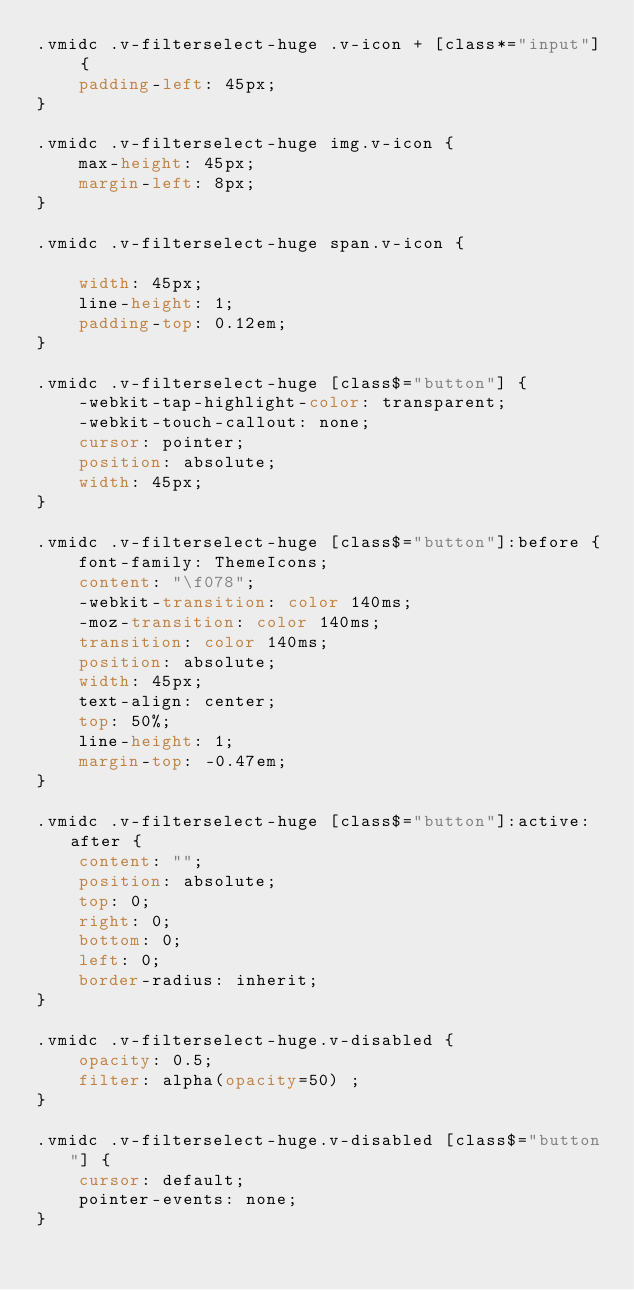Convert code to text. <code><loc_0><loc_0><loc_500><loc_500><_CSS_>.vmidc .v-filterselect-huge .v-icon + [class*="input"] {
	padding-left: 45px;
}

.vmidc .v-filterselect-huge img.v-icon {
	max-height: 45px;
	margin-left: 8px;
}

.vmidc .v-filterselect-huge span.v-icon {
	
	width: 45px;
	line-height: 1;
	padding-top: 0.12em;
}

.vmidc .v-filterselect-huge [class$="button"] {
	-webkit-tap-highlight-color: transparent;
	-webkit-touch-callout: none;
	cursor: pointer;
	position: absolute;
	width: 45px;
}

.vmidc .v-filterselect-huge [class$="button"]:before {
	font-family: ThemeIcons;
	content: "\f078";
	-webkit-transition: color 140ms;
	-moz-transition: color 140ms;
	transition: color 140ms;
	position: absolute;
	width: 45px;
	text-align: center;
	top: 50%;
	line-height: 1;
	margin-top: -0.47em;
}

.vmidc .v-filterselect-huge [class$="button"]:active:after {
	content: "";
	position: absolute;
	top: 0;
	right: 0;
	bottom: 0;
	left: 0;
	border-radius: inherit;
}

.vmidc .v-filterselect-huge.v-disabled {
	opacity: 0.5;
	filter: alpha(opacity=50) ;
}

.vmidc .v-filterselect-huge.v-disabled [class$="button"] {
	cursor: default;
	pointer-events: none;
}
</code> 